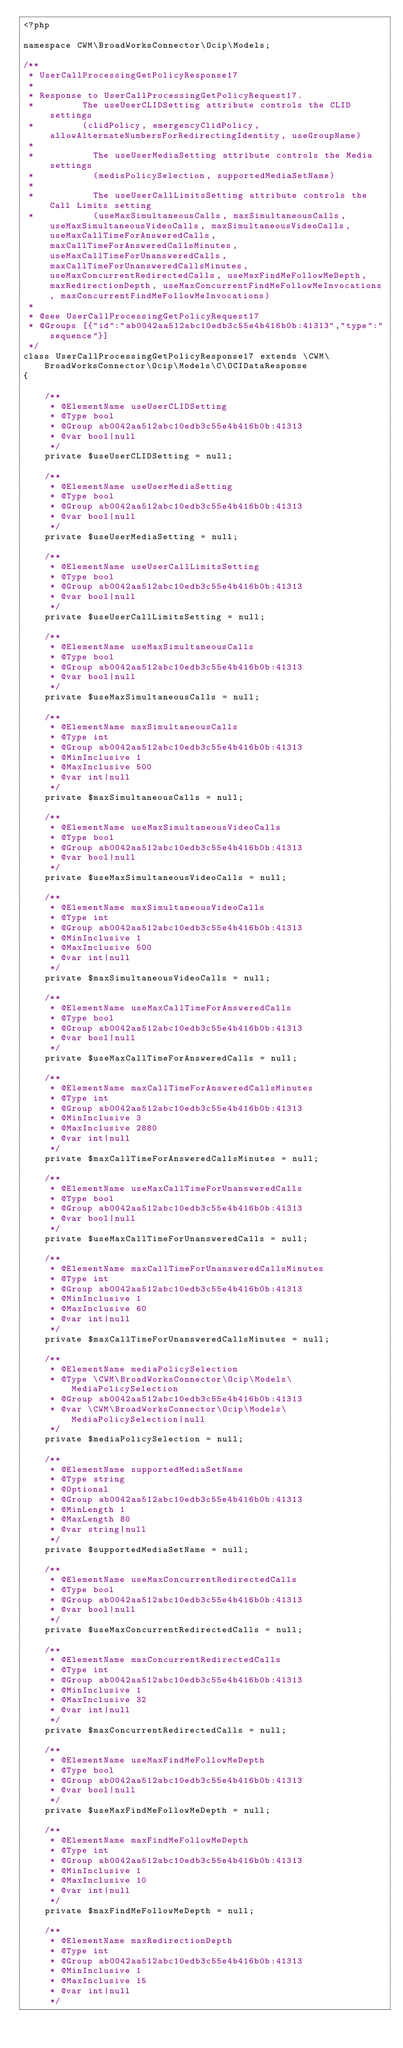Convert code to text. <code><loc_0><loc_0><loc_500><loc_500><_PHP_><?php

namespace CWM\BroadWorksConnector\Ocip\Models;

/**
 * UserCallProcessingGetPolicyResponse17
 *
 * Response to UserCallProcessingGetPolicyRequest17.
 *         The useUserCLIDSetting attribute controls the CLID settings 
 *         (clidPolicy, emergencyClidPolicy, allowAlternateNumbersForRedirectingIdentity, useGroupName)
 *         
 *           The useUserMediaSetting attribute controls the Media settings 
 *           (medisPolicySelection, supportedMediaSetName)
 *           
 *           The useUserCallLimitsSetting attribute controls the Call Limits setting 
 *           (useMaxSimultaneousCalls, maxSimultaneousCalls, useMaxSimultaneousVideoCalls, maxSimultaneousVideoCalls, useMaxCallTimeForAnsweredCalls, maxCallTimeForAnsweredCallsMinutes, useMaxCallTimeForUnansweredCalls, maxCallTimeForUnansweredCallsMinutes, useMaxConcurrentRedirectedCalls, useMaxFindMeFollowMeDepth, maxRedirectionDepth, useMaxConcurrentFindMeFollowMeInvocations, maxConcurrentFindMeFollowMeInvocations)
 *
 * @see UserCallProcessingGetPolicyRequest17
 * @Groups [{"id":"ab0042aa512abc10edb3c55e4b416b0b:41313","type":"sequence"}]
 */
class UserCallProcessingGetPolicyResponse17 extends \CWM\BroadWorksConnector\Ocip\Models\C\OCIDataResponse
{

    /**
     * @ElementName useUserCLIDSetting
     * @Type bool
     * @Group ab0042aa512abc10edb3c55e4b416b0b:41313
     * @var bool|null
     */
    private $useUserCLIDSetting = null;

    /**
     * @ElementName useUserMediaSetting
     * @Type bool
     * @Group ab0042aa512abc10edb3c55e4b416b0b:41313
     * @var bool|null
     */
    private $useUserMediaSetting = null;

    /**
     * @ElementName useUserCallLimitsSetting
     * @Type bool
     * @Group ab0042aa512abc10edb3c55e4b416b0b:41313
     * @var bool|null
     */
    private $useUserCallLimitsSetting = null;

    /**
     * @ElementName useMaxSimultaneousCalls
     * @Type bool
     * @Group ab0042aa512abc10edb3c55e4b416b0b:41313
     * @var bool|null
     */
    private $useMaxSimultaneousCalls = null;

    /**
     * @ElementName maxSimultaneousCalls
     * @Type int
     * @Group ab0042aa512abc10edb3c55e4b416b0b:41313
     * @MinInclusive 1
     * @MaxInclusive 500
     * @var int|null
     */
    private $maxSimultaneousCalls = null;

    /**
     * @ElementName useMaxSimultaneousVideoCalls
     * @Type bool
     * @Group ab0042aa512abc10edb3c55e4b416b0b:41313
     * @var bool|null
     */
    private $useMaxSimultaneousVideoCalls = null;

    /**
     * @ElementName maxSimultaneousVideoCalls
     * @Type int
     * @Group ab0042aa512abc10edb3c55e4b416b0b:41313
     * @MinInclusive 1
     * @MaxInclusive 500
     * @var int|null
     */
    private $maxSimultaneousVideoCalls = null;

    /**
     * @ElementName useMaxCallTimeForAnsweredCalls
     * @Type bool
     * @Group ab0042aa512abc10edb3c55e4b416b0b:41313
     * @var bool|null
     */
    private $useMaxCallTimeForAnsweredCalls = null;

    /**
     * @ElementName maxCallTimeForAnsweredCallsMinutes
     * @Type int
     * @Group ab0042aa512abc10edb3c55e4b416b0b:41313
     * @MinInclusive 3
     * @MaxInclusive 2880
     * @var int|null
     */
    private $maxCallTimeForAnsweredCallsMinutes = null;

    /**
     * @ElementName useMaxCallTimeForUnansweredCalls
     * @Type bool
     * @Group ab0042aa512abc10edb3c55e4b416b0b:41313
     * @var bool|null
     */
    private $useMaxCallTimeForUnansweredCalls = null;

    /**
     * @ElementName maxCallTimeForUnansweredCallsMinutes
     * @Type int
     * @Group ab0042aa512abc10edb3c55e4b416b0b:41313
     * @MinInclusive 1
     * @MaxInclusive 60
     * @var int|null
     */
    private $maxCallTimeForUnansweredCallsMinutes = null;

    /**
     * @ElementName mediaPolicySelection
     * @Type \CWM\BroadWorksConnector\Ocip\Models\MediaPolicySelection
     * @Group ab0042aa512abc10edb3c55e4b416b0b:41313
     * @var \CWM\BroadWorksConnector\Ocip\Models\MediaPolicySelection|null
     */
    private $mediaPolicySelection = null;

    /**
     * @ElementName supportedMediaSetName
     * @Type string
     * @Optional
     * @Group ab0042aa512abc10edb3c55e4b416b0b:41313
     * @MinLength 1
     * @MaxLength 80
     * @var string|null
     */
    private $supportedMediaSetName = null;

    /**
     * @ElementName useMaxConcurrentRedirectedCalls
     * @Type bool
     * @Group ab0042aa512abc10edb3c55e4b416b0b:41313
     * @var bool|null
     */
    private $useMaxConcurrentRedirectedCalls = null;

    /**
     * @ElementName maxConcurrentRedirectedCalls
     * @Type int
     * @Group ab0042aa512abc10edb3c55e4b416b0b:41313
     * @MinInclusive 1
     * @MaxInclusive 32
     * @var int|null
     */
    private $maxConcurrentRedirectedCalls = null;

    /**
     * @ElementName useMaxFindMeFollowMeDepth
     * @Type bool
     * @Group ab0042aa512abc10edb3c55e4b416b0b:41313
     * @var bool|null
     */
    private $useMaxFindMeFollowMeDepth = null;

    /**
     * @ElementName maxFindMeFollowMeDepth
     * @Type int
     * @Group ab0042aa512abc10edb3c55e4b416b0b:41313
     * @MinInclusive 1
     * @MaxInclusive 10
     * @var int|null
     */
    private $maxFindMeFollowMeDepth = null;

    /**
     * @ElementName maxRedirectionDepth
     * @Type int
     * @Group ab0042aa512abc10edb3c55e4b416b0b:41313
     * @MinInclusive 1
     * @MaxInclusive 15
     * @var int|null
     */</code> 